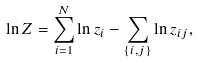Convert formula to latex. <formula><loc_0><loc_0><loc_500><loc_500>\ln Z = \sum _ { i = 1 } ^ { N } \ln z _ { i } - \sum _ { \{ i , j \} } \ln z _ { i j } ,</formula> 